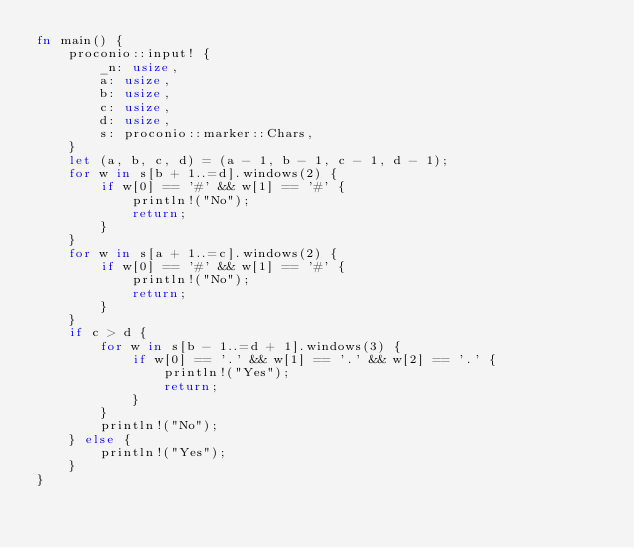<code> <loc_0><loc_0><loc_500><loc_500><_Rust_>fn main() {
    proconio::input! {
        _n: usize,
        a: usize,
        b: usize,
        c: usize,
        d: usize,
        s: proconio::marker::Chars,
    }
    let (a, b, c, d) = (a - 1, b - 1, c - 1, d - 1);
    for w in s[b + 1..=d].windows(2) {
        if w[0] == '#' && w[1] == '#' {
            println!("No");
            return;
        }
    }
    for w in s[a + 1..=c].windows(2) {
        if w[0] == '#' && w[1] == '#' {
            println!("No");
            return;
        }
    }
    if c > d {
        for w in s[b - 1..=d + 1].windows(3) {
            if w[0] == '.' && w[1] == '.' && w[2] == '.' {
                println!("Yes");
                return;
            }
        }
        println!("No");
    } else {
        println!("Yes");
    }
}
</code> 